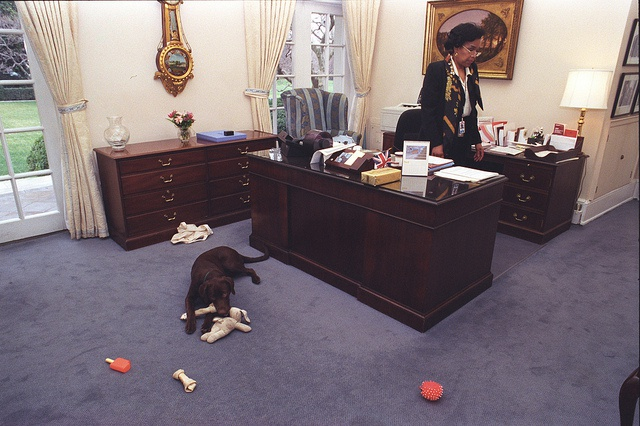Describe the objects in this image and their specific colors. I can see people in black, brown, maroon, and gray tones, dog in black, gray, and purple tones, chair in black, gray, darkgray, and purple tones, chair in black, maroon, gray, and ivory tones, and vase in black, tan, lightgray, and darkgray tones in this image. 